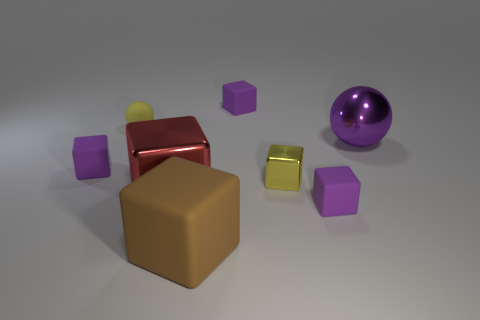There is a rubber thing that is both behind the purple metallic ball and left of the red object; what is its size?
Make the answer very short. Small. There is a ball on the right side of the big brown matte object; does it have the same color as the metallic cube that is behind the big red metal cube?
Your answer should be compact. No. There is a metallic block left of the big rubber thing that is in front of the metallic cube that is on the left side of the brown thing; how big is it?
Make the answer very short. Large. There is another shiny object that is the same shape as the tiny shiny thing; what is its color?
Give a very brief answer. Red. Is the number of large shiny objects that are to the left of the large metallic sphere greater than the number of gray shiny spheres?
Offer a terse response. Yes. Do the big rubber thing and the tiny purple rubber thing in front of the small metal block have the same shape?
Offer a terse response. Yes. There is a brown rubber thing that is the same shape as the yellow shiny thing; what size is it?
Give a very brief answer. Large. Are there more big yellow cylinders than purple metal objects?
Your answer should be very brief. No. Is the shape of the big red metal object the same as the large brown object?
Ensure brevity in your answer.  Yes. There is a small purple object behind the purple rubber block that is to the left of the rubber sphere; what is its material?
Your response must be concise. Rubber. 